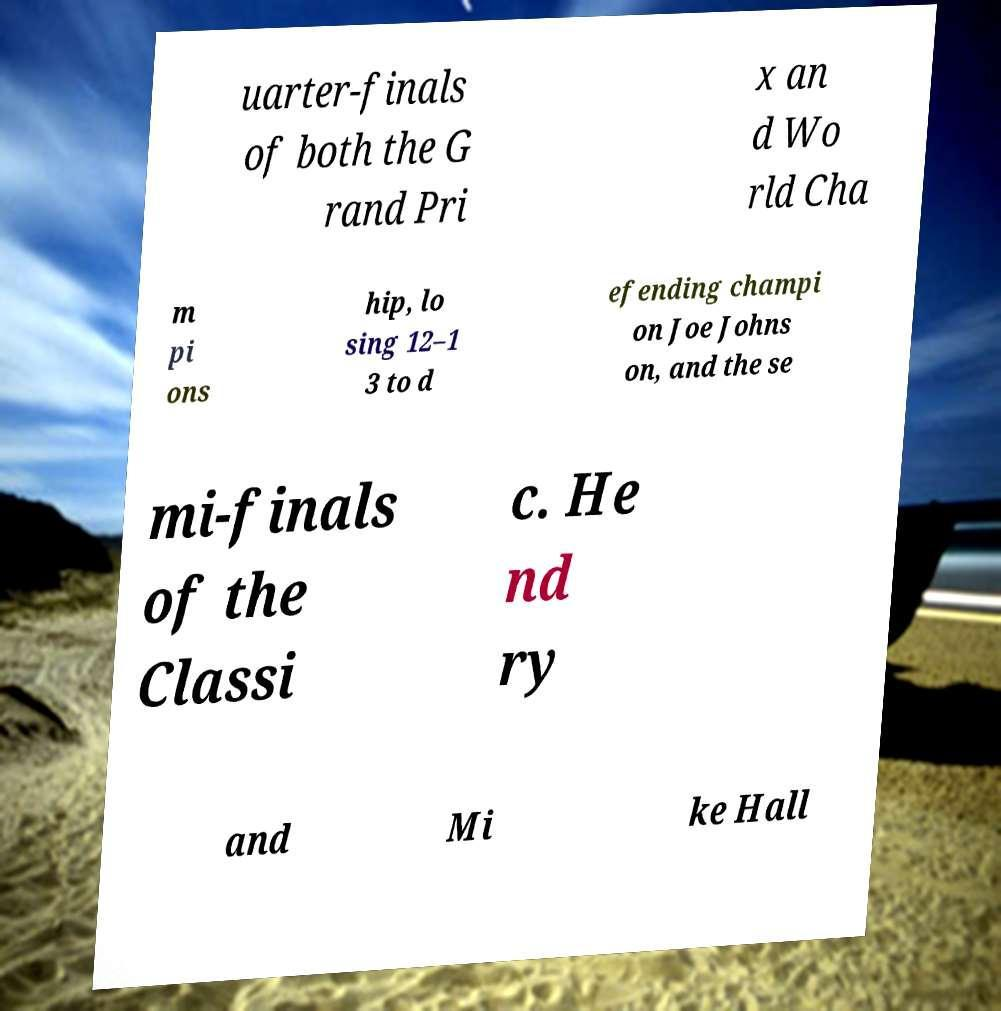Can you accurately transcribe the text from the provided image for me? uarter-finals of both the G rand Pri x an d Wo rld Cha m pi ons hip, lo sing 12–1 3 to d efending champi on Joe Johns on, and the se mi-finals of the Classi c. He nd ry and Mi ke Hall 